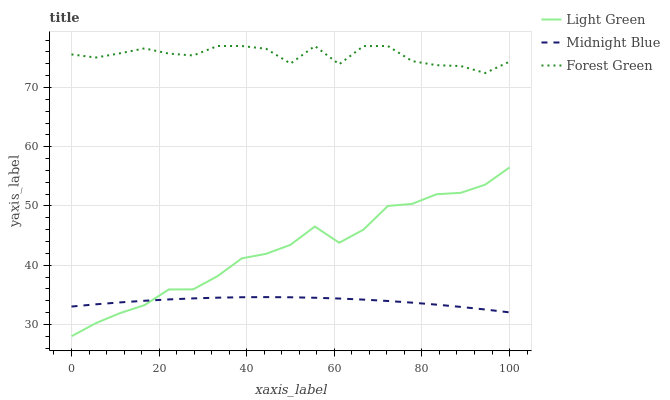Does Midnight Blue have the minimum area under the curve?
Answer yes or no. Yes. Does Forest Green have the maximum area under the curve?
Answer yes or no. Yes. Does Light Green have the minimum area under the curve?
Answer yes or no. No. Does Light Green have the maximum area under the curve?
Answer yes or no. No. Is Midnight Blue the smoothest?
Answer yes or no. Yes. Is Forest Green the roughest?
Answer yes or no. Yes. Is Light Green the smoothest?
Answer yes or no. No. Is Light Green the roughest?
Answer yes or no. No. Does Light Green have the lowest value?
Answer yes or no. Yes. Does Midnight Blue have the lowest value?
Answer yes or no. No. Does Forest Green have the highest value?
Answer yes or no. Yes. Does Light Green have the highest value?
Answer yes or no. No. Is Light Green less than Forest Green?
Answer yes or no. Yes. Is Forest Green greater than Midnight Blue?
Answer yes or no. Yes. Does Light Green intersect Midnight Blue?
Answer yes or no. Yes. Is Light Green less than Midnight Blue?
Answer yes or no. No. Is Light Green greater than Midnight Blue?
Answer yes or no. No. Does Light Green intersect Forest Green?
Answer yes or no. No. 